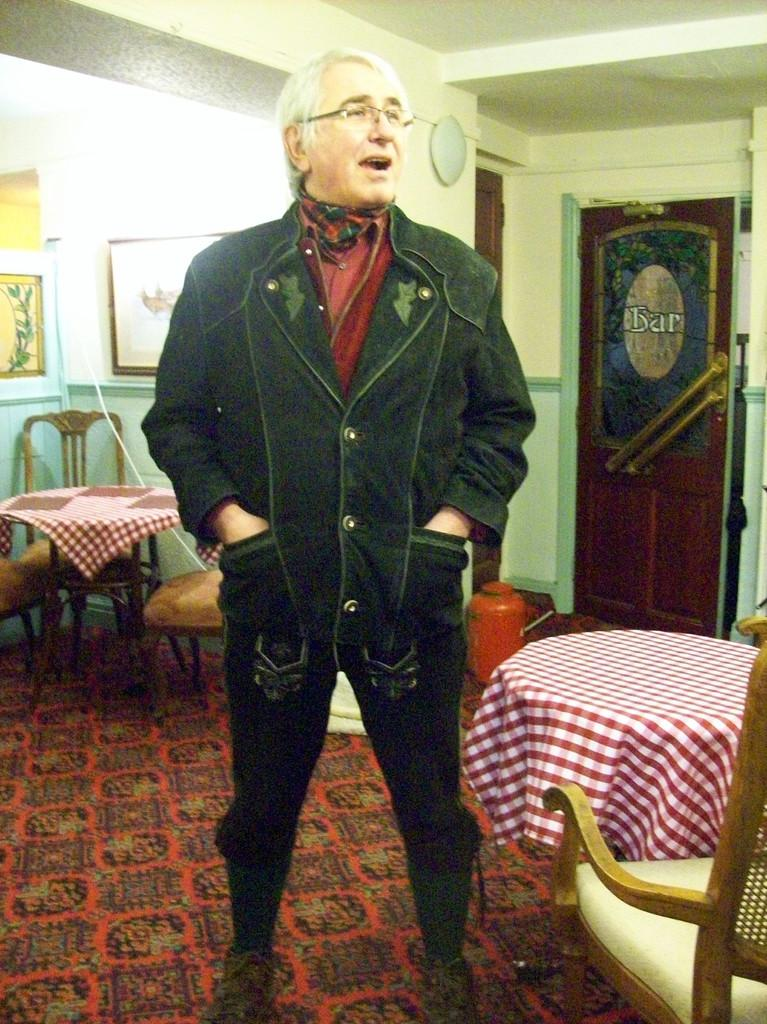Who or what is present in the image? There is a person in the image. What is the person wearing? The person is wearing a jacket. What type of furniture can be seen in the image? There are tables and chairs in the image. What is hanging on the wall in the image? There are frames on the wall in the image. What type of plant is growing on the person's head in the image? There is no plant growing on the person's head in the image. 